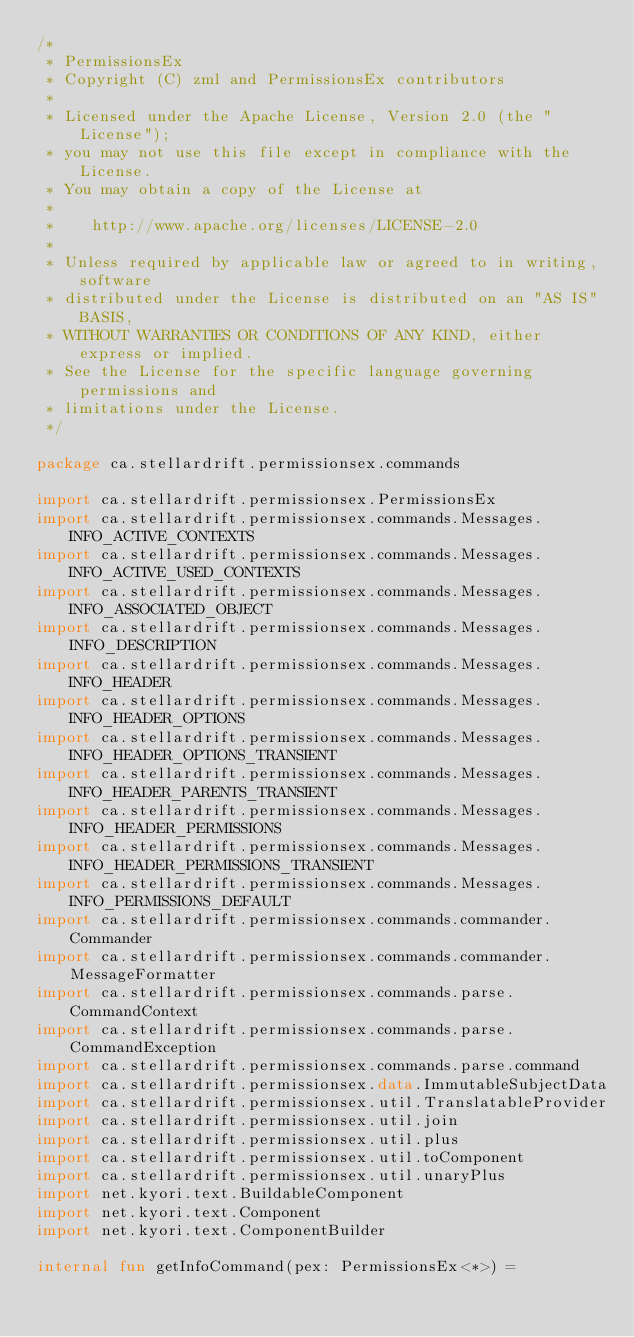Convert code to text. <code><loc_0><loc_0><loc_500><loc_500><_Kotlin_>/*
 * PermissionsEx
 * Copyright (C) zml and PermissionsEx contributors
 *
 * Licensed under the Apache License, Version 2.0 (the "License");
 * you may not use this file except in compliance with the License.
 * You may obtain a copy of the License at
 *
 *    http://www.apache.org/licenses/LICENSE-2.0
 *
 * Unless required by applicable law or agreed to in writing, software
 * distributed under the License is distributed on an "AS IS" BASIS,
 * WITHOUT WARRANTIES OR CONDITIONS OF ANY KIND, either express or implied.
 * See the License for the specific language governing permissions and
 * limitations under the License.
 */

package ca.stellardrift.permissionsex.commands

import ca.stellardrift.permissionsex.PermissionsEx
import ca.stellardrift.permissionsex.commands.Messages.INFO_ACTIVE_CONTEXTS
import ca.stellardrift.permissionsex.commands.Messages.INFO_ACTIVE_USED_CONTEXTS
import ca.stellardrift.permissionsex.commands.Messages.INFO_ASSOCIATED_OBJECT
import ca.stellardrift.permissionsex.commands.Messages.INFO_DESCRIPTION
import ca.stellardrift.permissionsex.commands.Messages.INFO_HEADER
import ca.stellardrift.permissionsex.commands.Messages.INFO_HEADER_OPTIONS
import ca.stellardrift.permissionsex.commands.Messages.INFO_HEADER_OPTIONS_TRANSIENT
import ca.stellardrift.permissionsex.commands.Messages.INFO_HEADER_PARENTS_TRANSIENT
import ca.stellardrift.permissionsex.commands.Messages.INFO_HEADER_PERMISSIONS
import ca.stellardrift.permissionsex.commands.Messages.INFO_HEADER_PERMISSIONS_TRANSIENT
import ca.stellardrift.permissionsex.commands.Messages.INFO_PERMISSIONS_DEFAULT
import ca.stellardrift.permissionsex.commands.commander.Commander
import ca.stellardrift.permissionsex.commands.commander.MessageFormatter
import ca.stellardrift.permissionsex.commands.parse.CommandContext
import ca.stellardrift.permissionsex.commands.parse.CommandException
import ca.stellardrift.permissionsex.commands.parse.command
import ca.stellardrift.permissionsex.data.ImmutableSubjectData
import ca.stellardrift.permissionsex.util.TranslatableProvider
import ca.stellardrift.permissionsex.util.join
import ca.stellardrift.permissionsex.util.plus
import ca.stellardrift.permissionsex.util.toComponent
import ca.stellardrift.permissionsex.util.unaryPlus
import net.kyori.text.BuildableComponent
import net.kyori.text.Component
import net.kyori.text.ComponentBuilder

internal fun getInfoCommand(pex: PermissionsEx<*>) =</code> 